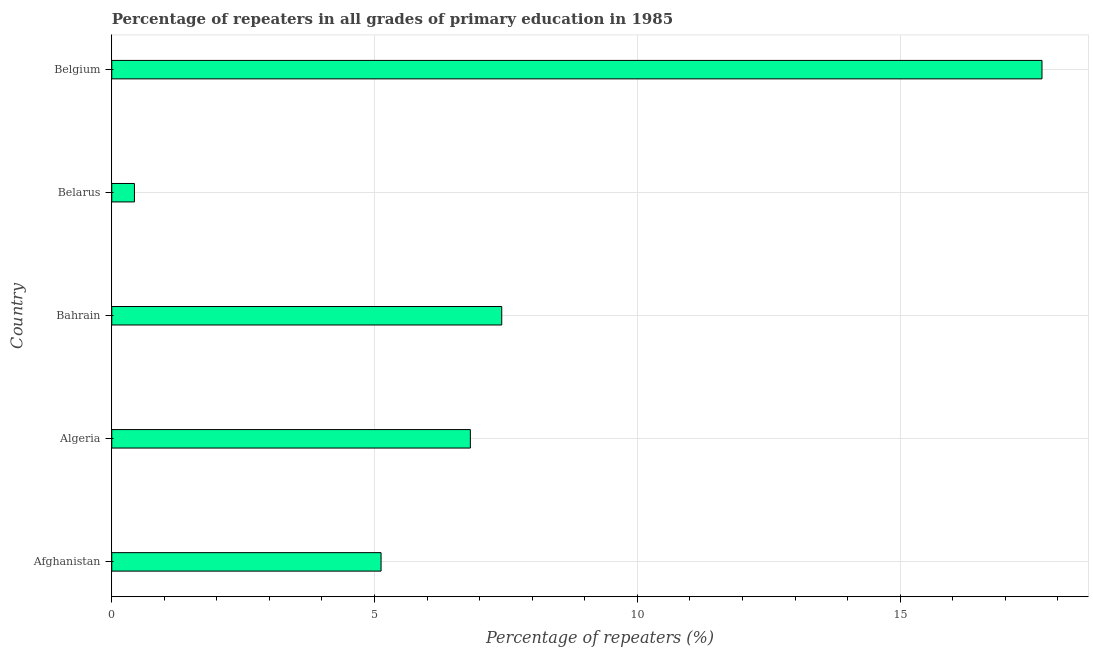Does the graph contain any zero values?
Offer a terse response. No. Does the graph contain grids?
Your answer should be compact. Yes. What is the title of the graph?
Provide a short and direct response. Percentage of repeaters in all grades of primary education in 1985. What is the label or title of the X-axis?
Your answer should be compact. Percentage of repeaters (%). What is the label or title of the Y-axis?
Offer a terse response. Country. What is the percentage of repeaters in primary education in Afghanistan?
Make the answer very short. 5.12. Across all countries, what is the maximum percentage of repeaters in primary education?
Offer a terse response. 17.7. Across all countries, what is the minimum percentage of repeaters in primary education?
Make the answer very short. 0.43. In which country was the percentage of repeaters in primary education maximum?
Provide a short and direct response. Belgium. In which country was the percentage of repeaters in primary education minimum?
Provide a short and direct response. Belarus. What is the sum of the percentage of repeaters in primary education?
Your answer should be very brief. 37.5. What is the difference between the percentage of repeaters in primary education in Algeria and Bahrain?
Ensure brevity in your answer.  -0.6. What is the median percentage of repeaters in primary education?
Keep it short and to the point. 6.82. What is the ratio of the percentage of repeaters in primary education in Algeria to that in Bahrain?
Your answer should be very brief. 0.92. Is the difference between the percentage of repeaters in primary education in Afghanistan and Belgium greater than the difference between any two countries?
Your response must be concise. No. What is the difference between the highest and the second highest percentage of repeaters in primary education?
Keep it short and to the point. 10.28. What is the difference between the highest and the lowest percentage of repeaters in primary education?
Your answer should be very brief. 17.27. In how many countries, is the percentage of repeaters in primary education greater than the average percentage of repeaters in primary education taken over all countries?
Make the answer very short. 1. How many bars are there?
Give a very brief answer. 5. How many countries are there in the graph?
Your response must be concise. 5. What is the difference between two consecutive major ticks on the X-axis?
Provide a succinct answer. 5. Are the values on the major ticks of X-axis written in scientific E-notation?
Make the answer very short. No. What is the Percentage of repeaters (%) of Afghanistan?
Your answer should be very brief. 5.12. What is the Percentage of repeaters (%) in Algeria?
Provide a succinct answer. 6.82. What is the Percentage of repeaters (%) in Bahrain?
Ensure brevity in your answer.  7.42. What is the Percentage of repeaters (%) in Belarus?
Give a very brief answer. 0.43. What is the Percentage of repeaters (%) in Belgium?
Give a very brief answer. 17.7. What is the difference between the Percentage of repeaters (%) in Afghanistan and Algeria?
Your answer should be compact. -1.7. What is the difference between the Percentage of repeaters (%) in Afghanistan and Bahrain?
Offer a very short reply. -2.3. What is the difference between the Percentage of repeaters (%) in Afghanistan and Belarus?
Your answer should be very brief. 4.69. What is the difference between the Percentage of repeaters (%) in Afghanistan and Belgium?
Provide a short and direct response. -12.58. What is the difference between the Percentage of repeaters (%) in Algeria and Bahrain?
Provide a short and direct response. -0.6. What is the difference between the Percentage of repeaters (%) in Algeria and Belarus?
Ensure brevity in your answer.  6.39. What is the difference between the Percentage of repeaters (%) in Algeria and Belgium?
Ensure brevity in your answer.  -10.88. What is the difference between the Percentage of repeaters (%) in Bahrain and Belarus?
Make the answer very short. 6.99. What is the difference between the Percentage of repeaters (%) in Bahrain and Belgium?
Your answer should be compact. -10.28. What is the difference between the Percentage of repeaters (%) in Belarus and Belgium?
Your answer should be very brief. -17.27. What is the ratio of the Percentage of repeaters (%) in Afghanistan to that in Algeria?
Provide a short and direct response. 0.75. What is the ratio of the Percentage of repeaters (%) in Afghanistan to that in Bahrain?
Your answer should be compact. 0.69. What is the ratio of the Percentage of repeaters (%) in Afghanistan to that in Belarus?
Your answer should be compact. 11.87. What is the ratio of the Percentage of repeaters (%) in Afghanistan to that in Belgium?
Offer a very short reply. 0.29. What is the ratio of the Percentage of repeaters (%) in Algeria to that in Bahrain?
Offer a very short reply. 0.92. What is the ratio of the Percentage of repeaters (%) in Algeria to that in Belgium?
Make the answer very short. 0.39. What is the ratio of the Percentage of repeaters (%) in Bahrain to that in Belarus?
Your answer should be very brief. 17.18. What is the ratio of the Percentage of repeaters (%) in Bahrain to that in Belgium?
Make the answer very short. 0.42. What is the ratio of the Percentage of repeaters (%) in Belarus to that in Belgium?
Give a very brief answer. 0.02. 